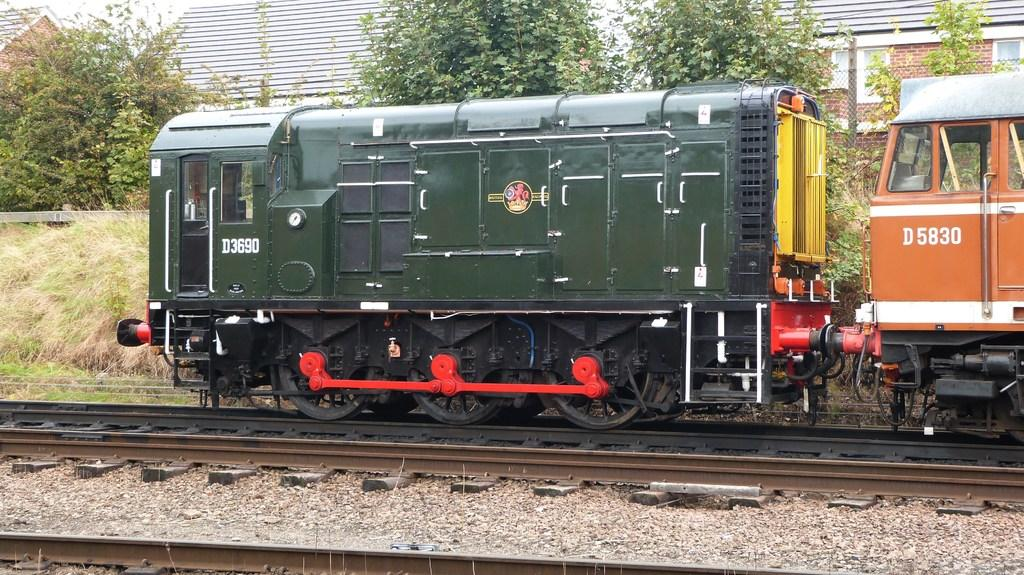<image>
Describe the image concisely. An old style train with D 5830 written on the side. 